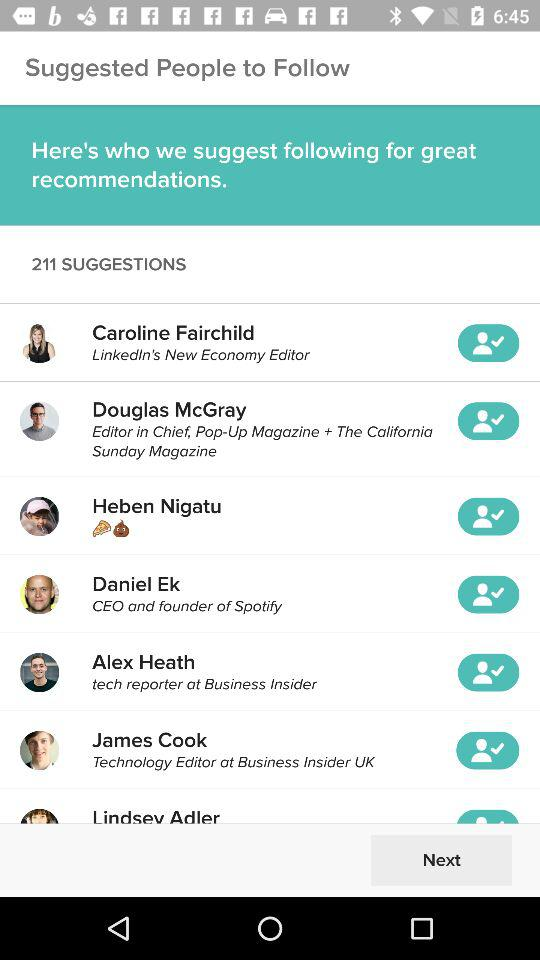How many suggestions in total are there? There are 211 suggestions in total. 